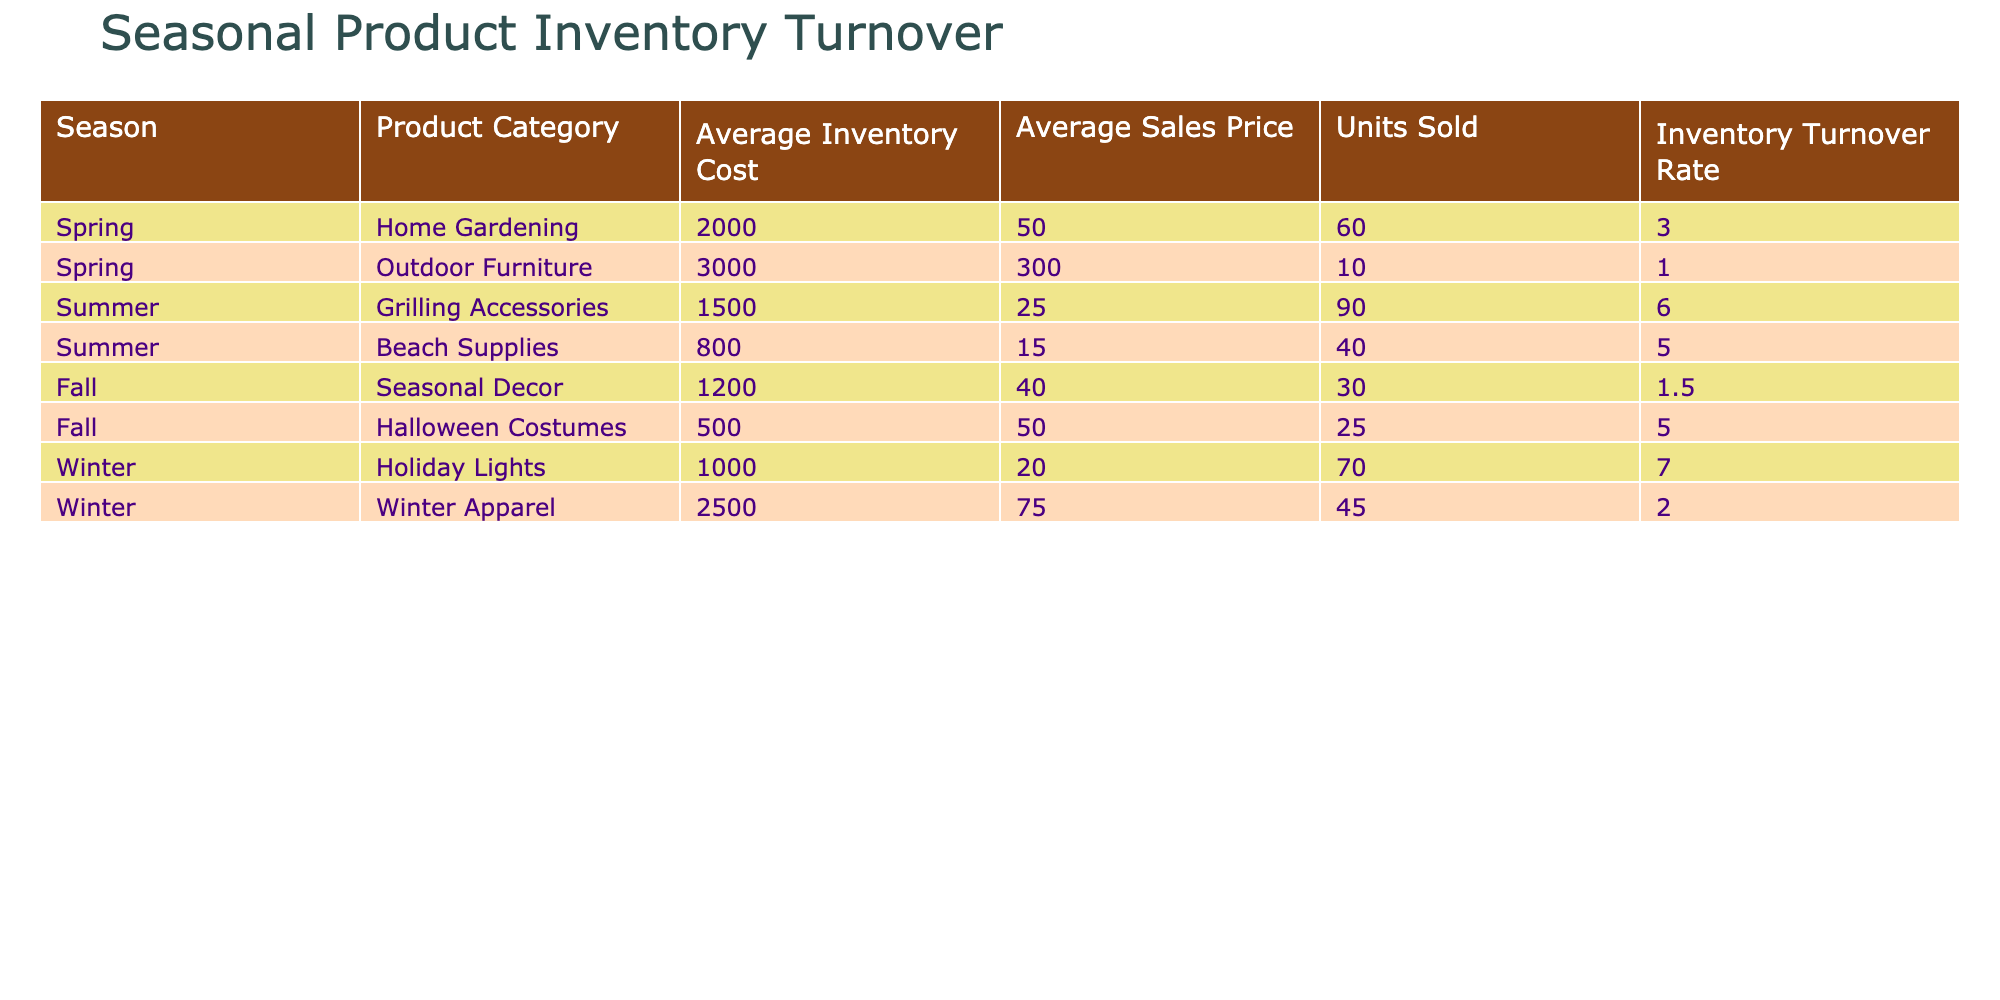What is the Inventory Turnover Rate for Summer Grilling Accessories? Looking at the table in the Summer section, the Inventory Turnover Rate for Grilling Accessories is provided directly under that category. It shows a rate of 6.0.
Answer: 6.0 Which product category has the highest Inventory Turnover Rate? Reviewing the entire table, I compare the Inventory Turnover Rates for each category. The highest value is 7.0, which corresponds to Holiday Lights in Winter.
Answer: Holiday Lights What is the average Inventory Turnover Rate for all seasonal product categories? To find the average, I first add up all the Inventory Turnover Rates: (3.0 + 1.0 + 6.0 + 5.0 + 1.5 + 5.0 + 7.0 + 2.0) = 30.0. Then, I divide by the number of categories, which is 8: 30.0 / 8 = 3.75.
Answer: 3.75 Is the average Sales Price for Fall Seasonal Decor higher than $50? The Sales Price for Seasonal Decor in Fall is listed as $40. Since $40 is less than $50, the answer is no.
Answer: No How many units were sold in total across all categories? I determine the total number of units sold by summing the Units Sold for each category: (60 + 10 + 90 + 40 + 30 + 25 + 70 + 45) = 370.
Answer: 370 Which season has the lowest average Inventory Cost? To find the season with the lowest average Inventory Cost, I compare the averages for each season: Spring (2000 + 3000), Summer (1500 + 800), Fall (1200 + 500), and Winter (1000 + 2500). The averages are Spring: 2500, Summer: 1150, Fall: 850, Winter: 1750. Since Fall has the lowest average, the answer is Fall.
Answer: Fall Do Grilling Accessories have a higher Average Sales Price than Beach Supplies? The Average Sales Price for Grilling Accessories is $25 and for Beach Supplies is $15. Since $25 > $15, the answer is yes.
Answer: Yes What is the difference in Inventory Turnover Rates between Halloween Costumes and Winter Apparel? The Inventory Turnover Rate for Halloween Costumes is 5.0, and for Winter Apparel, it is 2.0. The difference is calculated as 5.0 - 2.0 = 3.0.
Answer: 3.0 